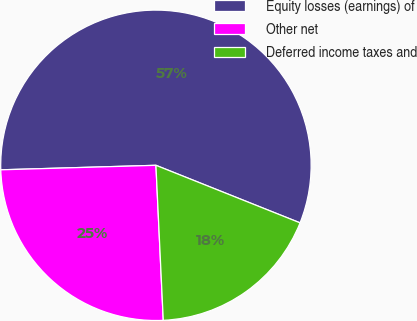<chart> <loc_0><loc_0><loc_500><loc_500><pie_chart><fcel>Equity losses (earnings) of<fcel>Other net<fcel>Deferred income taxes and<nl><fcel>56.51%<fcel>25.29%<fcel>18.2%<nl></chart> 